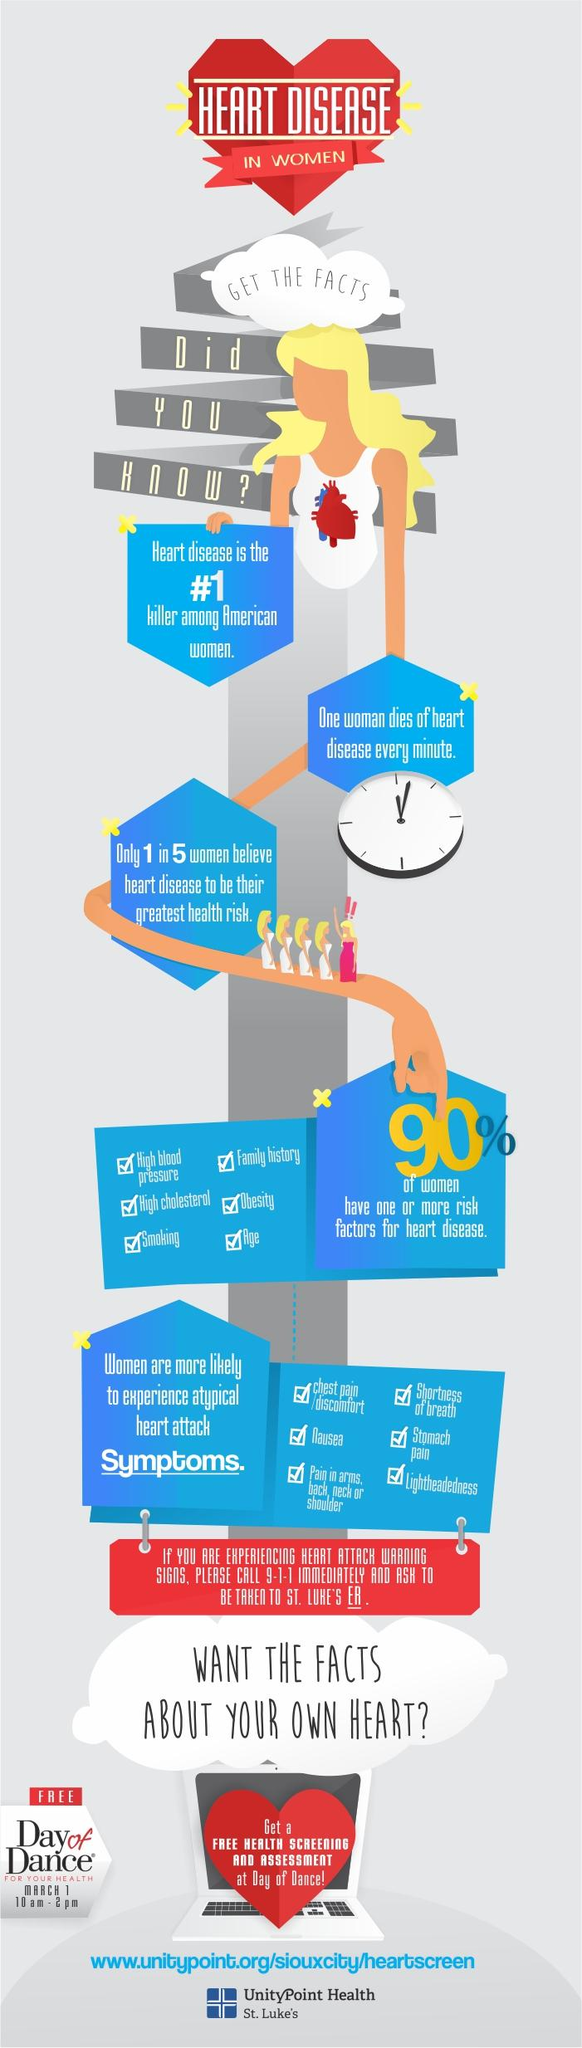Give some essential details in this illustration. According to a recent survey, 20% of women believe that heart disease is their greatest health risk. According to the provided information, it is indicated that 90% of the women have at least one risk factor for heart disease. Six symptoms of a heart attack are mentioned. According to estimates, approximately 60 women die from heart disease every hour in the United States. Six risk factors for heart disease are mentioned. 